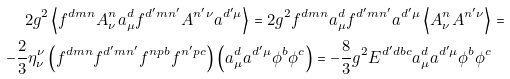Convert formula to latex. <formula><loc_0><loc_0><loc_500><loc_500>2 g ^ { 2 } \left \langle f ^ { d m n } A ^ { n } _ { \nu } a ^ { d } _ { \mu } f ^ { d ^ { \prime } m n ^ { \prime } } A ^ { n ^ { \prime } \nu } a ^ { d ^ { \prime } \mu } \right \rangle = 2 g ^ { 2 } f ^ { d m n } a ^ { d } _ { \mu } f ^ { d ^ { \prime } m n ^ { \prime } } a ^ { d ^ { \prime } \mu } \left \langle A ^ { n } _ { \nu } A ^ { n ^ { \prime } \nu } \right \rangle & = \\ - \frac { 2 } { 3 } \eta ^ { \nu } _ { \nu } \left ( f ^ { d m n } f ^ { d ^ { \prime } m n ^ { \prime } } f ^ { n p b } f ^ { n ^ { \prime } p c } \right ) \left ( a ^ { d } _ { \mu } a ^ { d ^ { \prime } \mu } \phi ^ { b } \phi ^ { c } \right ) = - \frac { 8 } { 3 } g ^ { 2 } E ^ { d ^ { \prime } d b c } a ^ { d } _ { \mu } a ^ { d ^ { \prime } \mu } \phi ^ { b } \phi ^ { c } &</formula> 